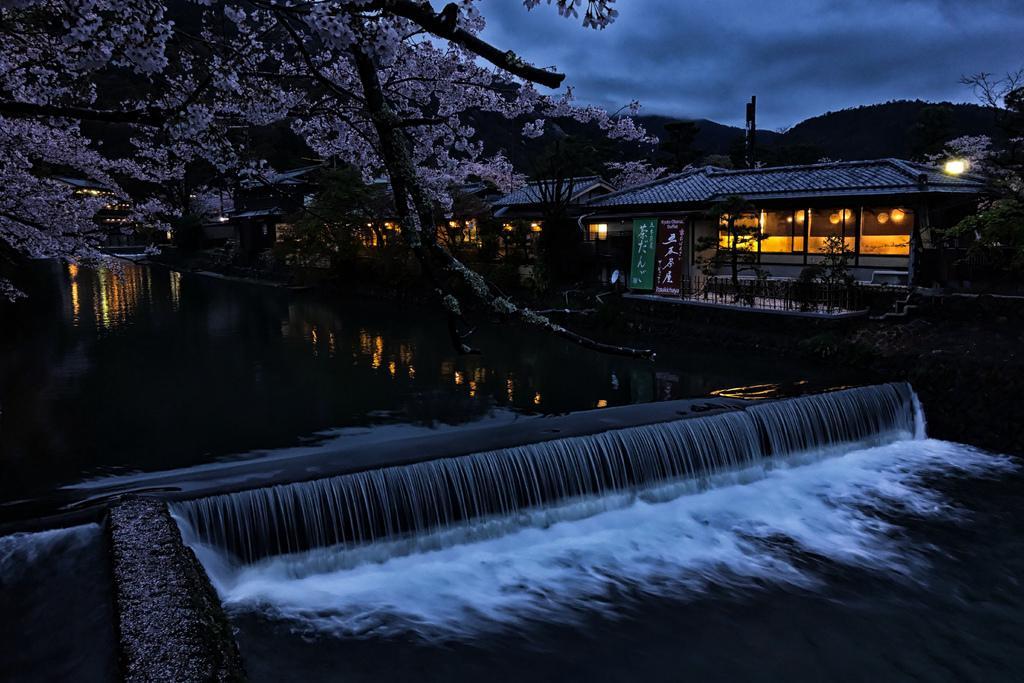Please provide a concise description of this image. In the image there is a waterfall in the front with pond and trees behind it, on the right side there are homes with lights in it and above its sky with clouds. 